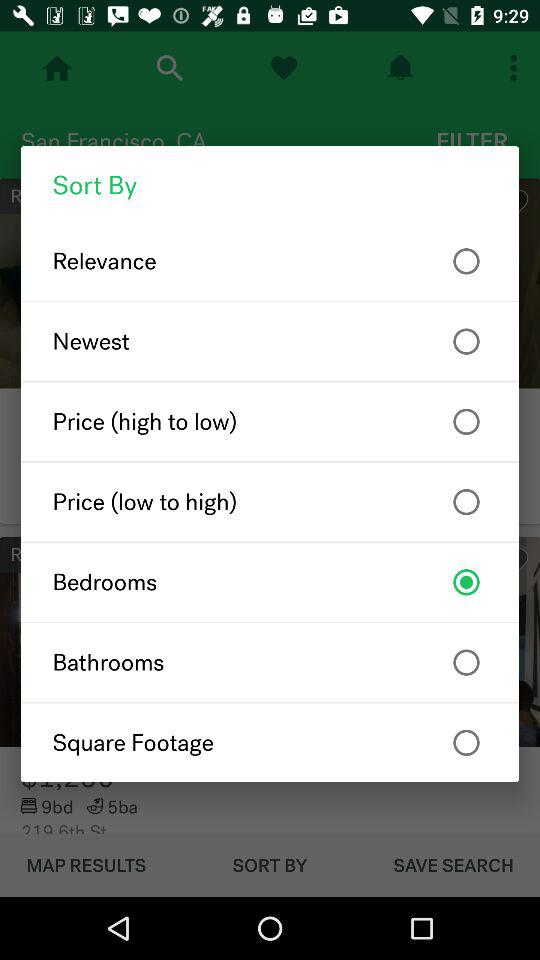Is "Newest" selected or not? The "Newest" is "not selected". 